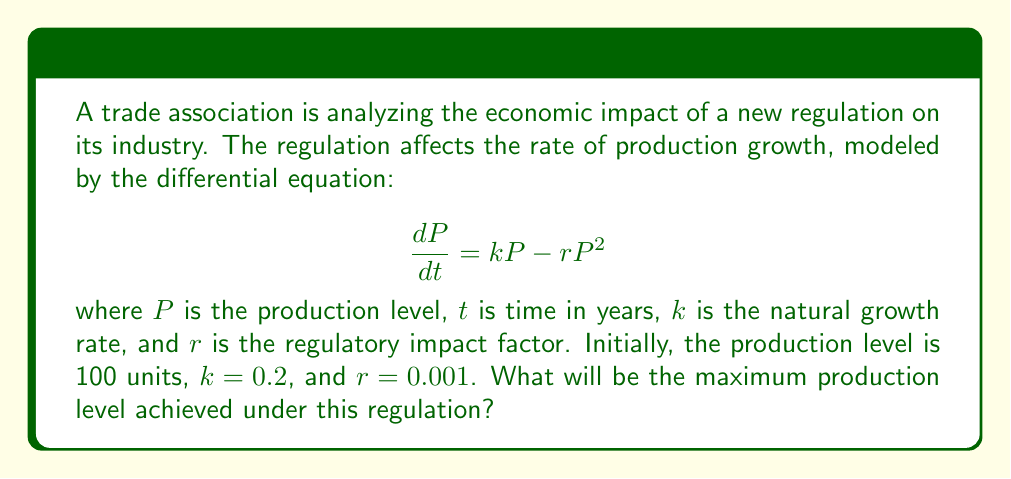Teach me how to tackle this problem. To find the maximum production level, we need to follow these steps:

1) The given differential equation is logistic growth model with regulatory impact:
   $$\frac{dP}{dt} = kP - rP^2$$

2) The maximum production level occurs when the rate of change is zero:
   $$\frac{dP}{dt} = 0$$

3) Substituting this into our equation:
   $$0 = kP - rP^2$$

4) Factoring out P:
   $$0 = P(k - rP)$$

5) Solving this equation:
   Either $P = 0$ (trivial solution) or $k - rP = 0$

6) Solving $k - rP = 0$:
   $$rP = k$$
   $$P = \frac{k}{r}$$

7) Substituting the given values:
   $$P = \frac{0.2}{0.001} = 200$$

Therefore, the maximum production level achieved under this regulation will be 200 units.
Answer: 200 units 